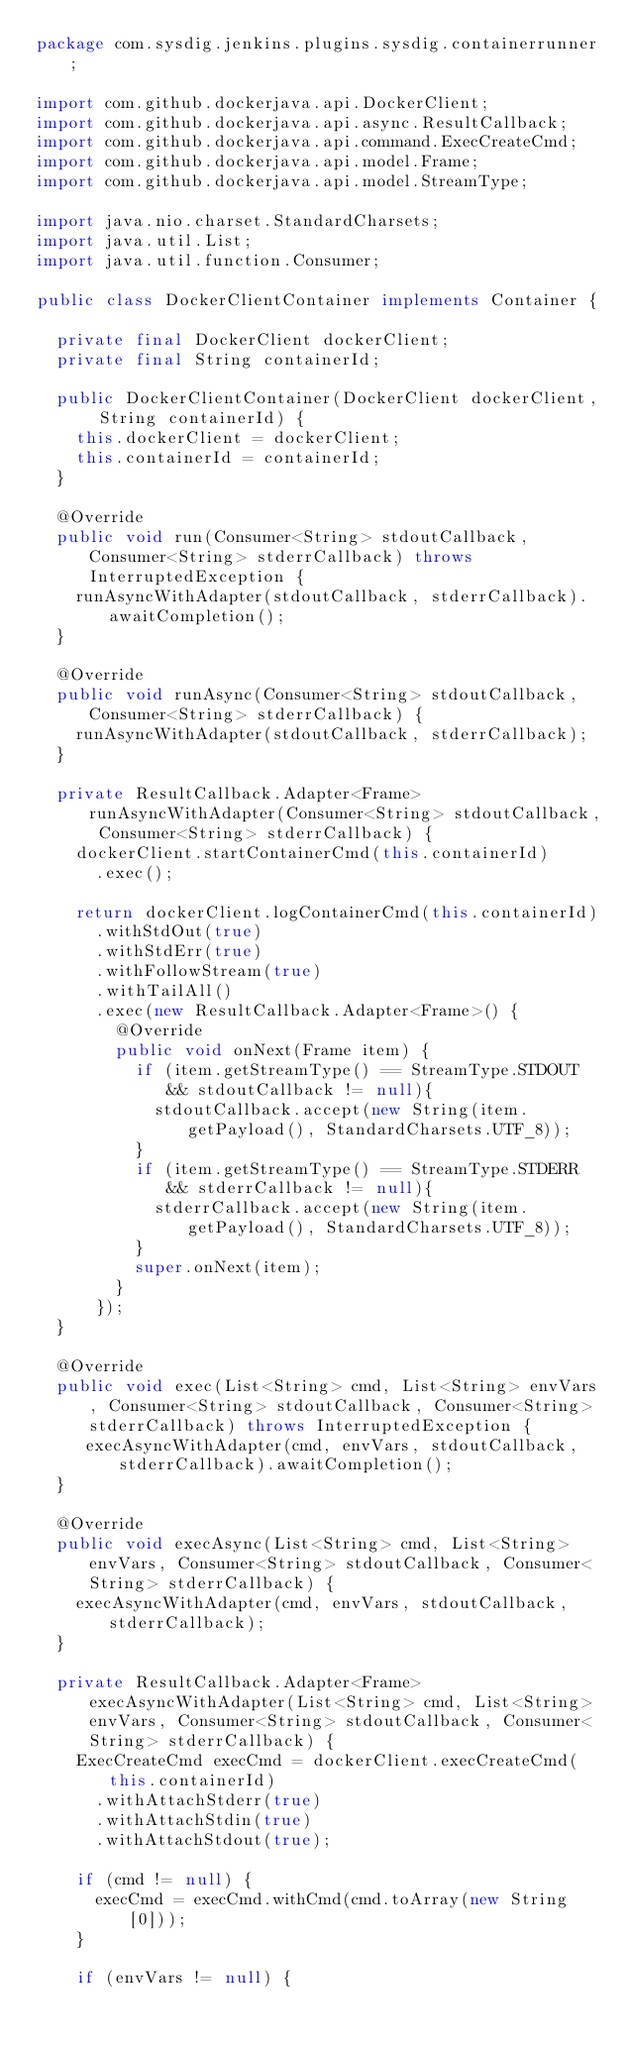<code> <loc_0><loc_0><loc_500><loc_500><_Java_>package com.sysdig.jenkins.plugins.sysdig.containerrunner;

import com.github.dockerjava.api.DockerClient;
import com.github.dockerjava.api.async.ResultCallback;
import com.github.dockerjava.api.command.ExecCreateCmd;
import com.github.dockerjava.api.model.Frame;
import com.github.dockerjava.api.model.StreamType;

import java.nio.charset.StandardCharsets;
import java.util.List;
import java.util.function.Consumer;

public class DockerClientContainer implements Container {

  private final DockerClient dockerClient;
  private final String containerId;

  public DockerClientContainer(DockerClient dockerClient, String containerId) {
    this.dockerClient = dockerClient;
    this.containerId = containerId;
  }

  @Override
  public void run(Consumer<String> stdoutCallback, Consumer<String> stderrCallback) throws InterruptedException {
    runAsyncWithAdapter(stdoutCallback, stderrCallback).awaitCompletion();
  }

  @Override
  public void runAsync(Consumer<String> stdoutCallback, Consumer<String> stderrCallback) {
    runAsyncWithAdapter(stdoutCallback, stderrCallback);
  }

  private ResultCallback.Adapter<Frame> runAsyncWithAdapter(Consumer<String> stdoutCallback, Consumer<String> stderrCallback) {
    dockerClient.startContainerCmd(this.containerId)
      .exec();

    return dockerClient.logContainerCmd(this.containerId)
      .withStdOut(true)
      .withStdErr(true)
      .withFollowStream(true)
      .withTailAll()
      .exec(new ResultCallback.Adapter<Frame>() {
        @Override
        public void onNext(Frame item) {
          if (item.getStreamType() == StreamType.STDOUT && stdoutCallback != null){
            stdoutCallback.accept(new String(item.getPayload(), StandardCharsets.UTF_8));
          }
          if (item.getStreamType() == StreamType.STDERR && stderrCallback != null){
            stderrCallback.accept(new String(item.getPayload(), StandardCharsets.UTF_8));
          }
          super.onNext(item);
        }
      });
  }

  @Override
  public void exec(List<String> cmd, List<String> envVars, Consumer<String> stdoutCallback, Consumer<String> stderrCallback) throws InterruptedException {
     execAsyncWithAdapter(cmd, envVars, stdoutCallback, stderrCallback).awaitCompletion();
  }

  @Override
  public void execAsync(List<String> cmd, List<String> envVars, Consumer<String> stdoutCallback, Consumer<String> stderrCallback) {
    execAsyncWithAdapter(cmd, envVars, stdoutCallback, stderrCallback);
  }

  private ResultCallback.Adapter<Frame> execAsyncWithAdapter(List<String> cmd, List<String> envVars, Consumer<String> stdoutCallback, Consumer<String> stderrCallback) {
    ExecCreateCmd execCmd = dockerClient.execCreateCmd(this.containerId)
      .withAttachStderr(true)
      .withAttachStdin(true)
      .withAttachStdout(true);

    if (cmd != null) {
      execCmd = execCmd.withCmd(cmd.toArray(new String[0]));
    }

    if (envVars != null) {</code> 